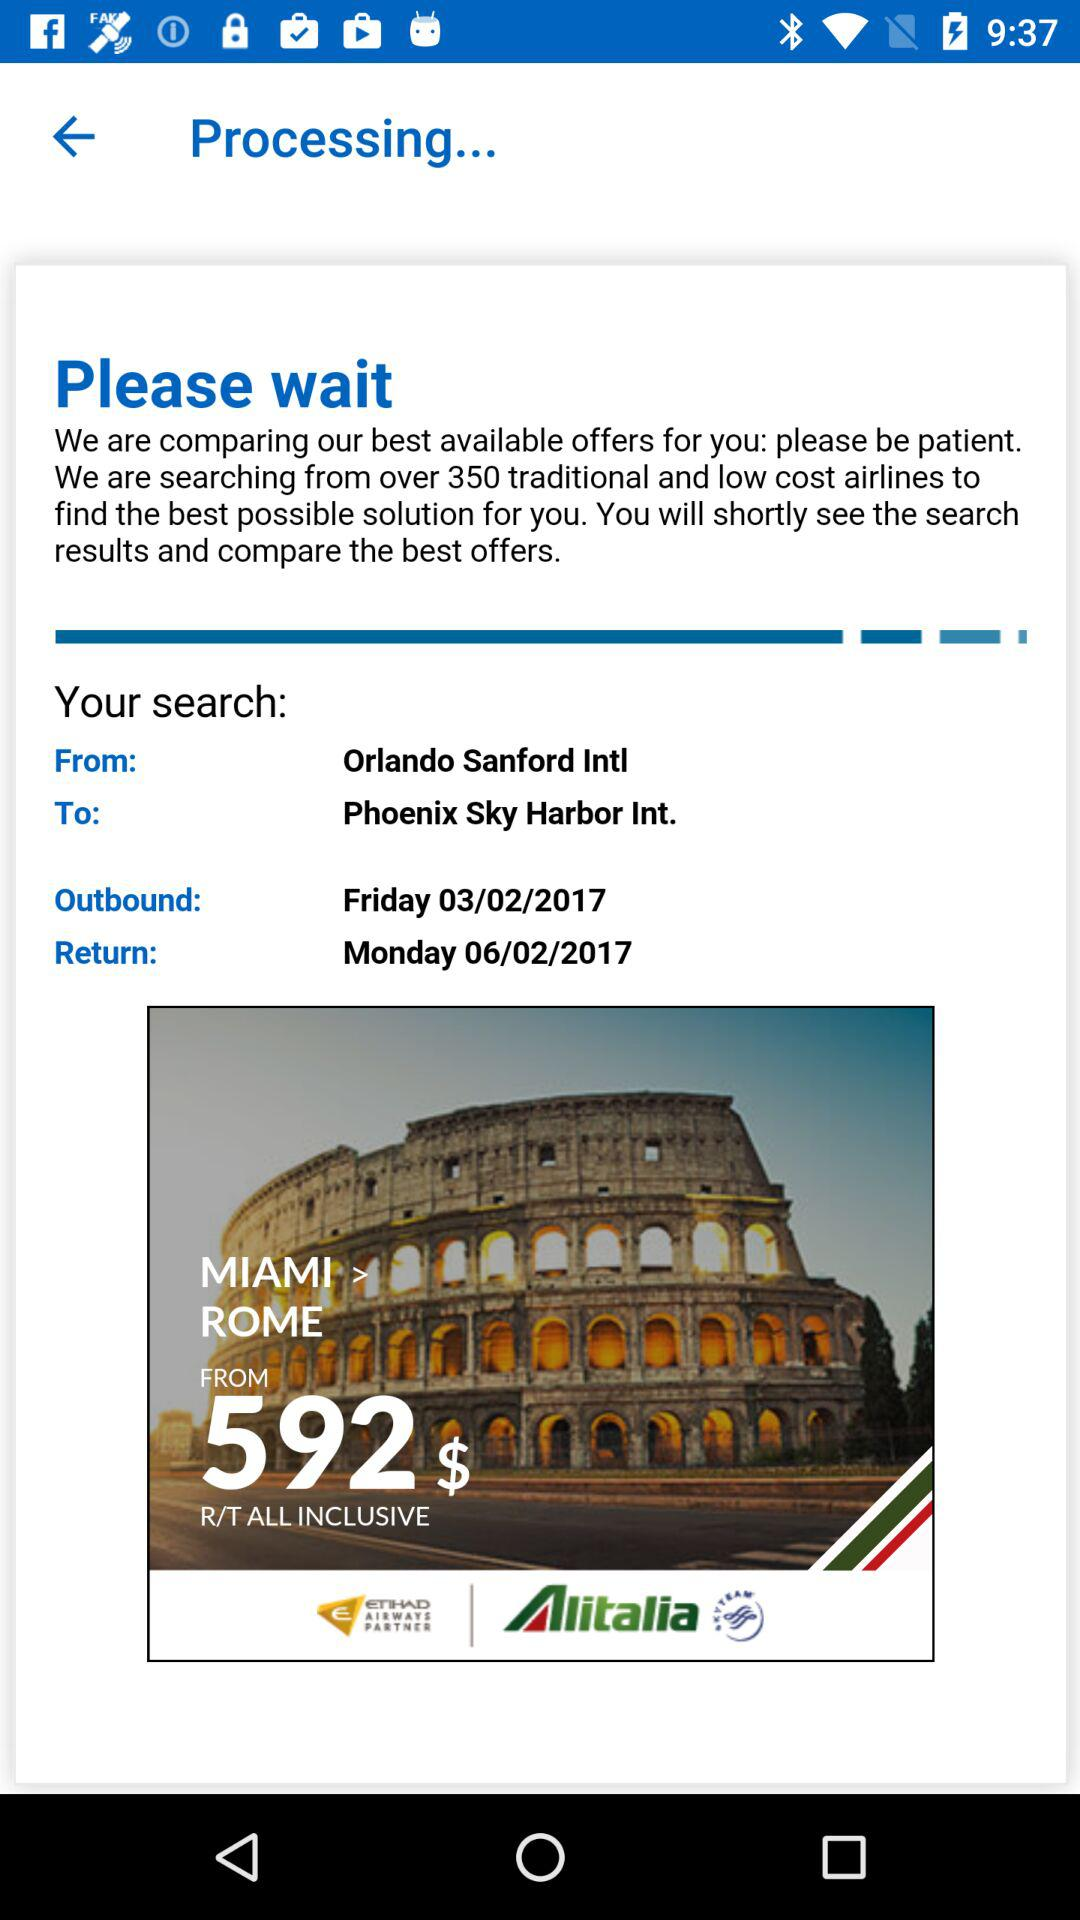What is the arrival location? The arrival location is Phoenix Sky Harbor Int. 